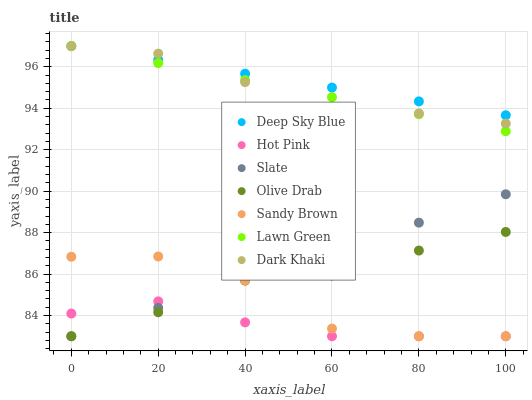Does Hot Pink have the minimum area under the curve?
Answer yes or no. Yes. Does Deep Sky Blue have the maximum area under the curve?
Answer yes or no. Yes. Does Slate have the minimum area under the curve?
Answer yes or no. No. Does Slate have the maximum area under the curve?
Answer yes or no. No. Is Slate the smoothest?
Answer yes or no. Yes. Is Sandy Brown the roughest?
Answer yes or no. Yes. Is Hot Pink the smoothest?
Answer yes or no. No. Is Hot Pink the roughest?
Answer yes or no. No. Does Slate have the lowest value?
Answer yes or no. Yes. Does Dark Khaki have the lowest value?
Answer yes or no. No. Does Deep Sky Blue have the highest value?
Answer yes or no. Yes. Does Slate have the highest value?
Answer yes or no. No. Is Hot Pink less than Dark Khaki?
Answer yes or no. Yes. Is Lawn Green greater than Sandy Brown?
Answer yes or no. Yes. Does Lawn Green intersect Dark Khaki?
Answer yes or no. Yes. Is Lawn Green less than Dark Khaki?
Answer yes or no. No. Is Lawn Green greater than Dark Khaki?
Answer yes or no. No. Does Hot Pink intersect Dark Khaki?
Answer yes or no. No. 